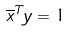<formula> <loc_0><loc_0><loc_500><loc_500>\overline { x } ^ { T } y = 1</formula> 